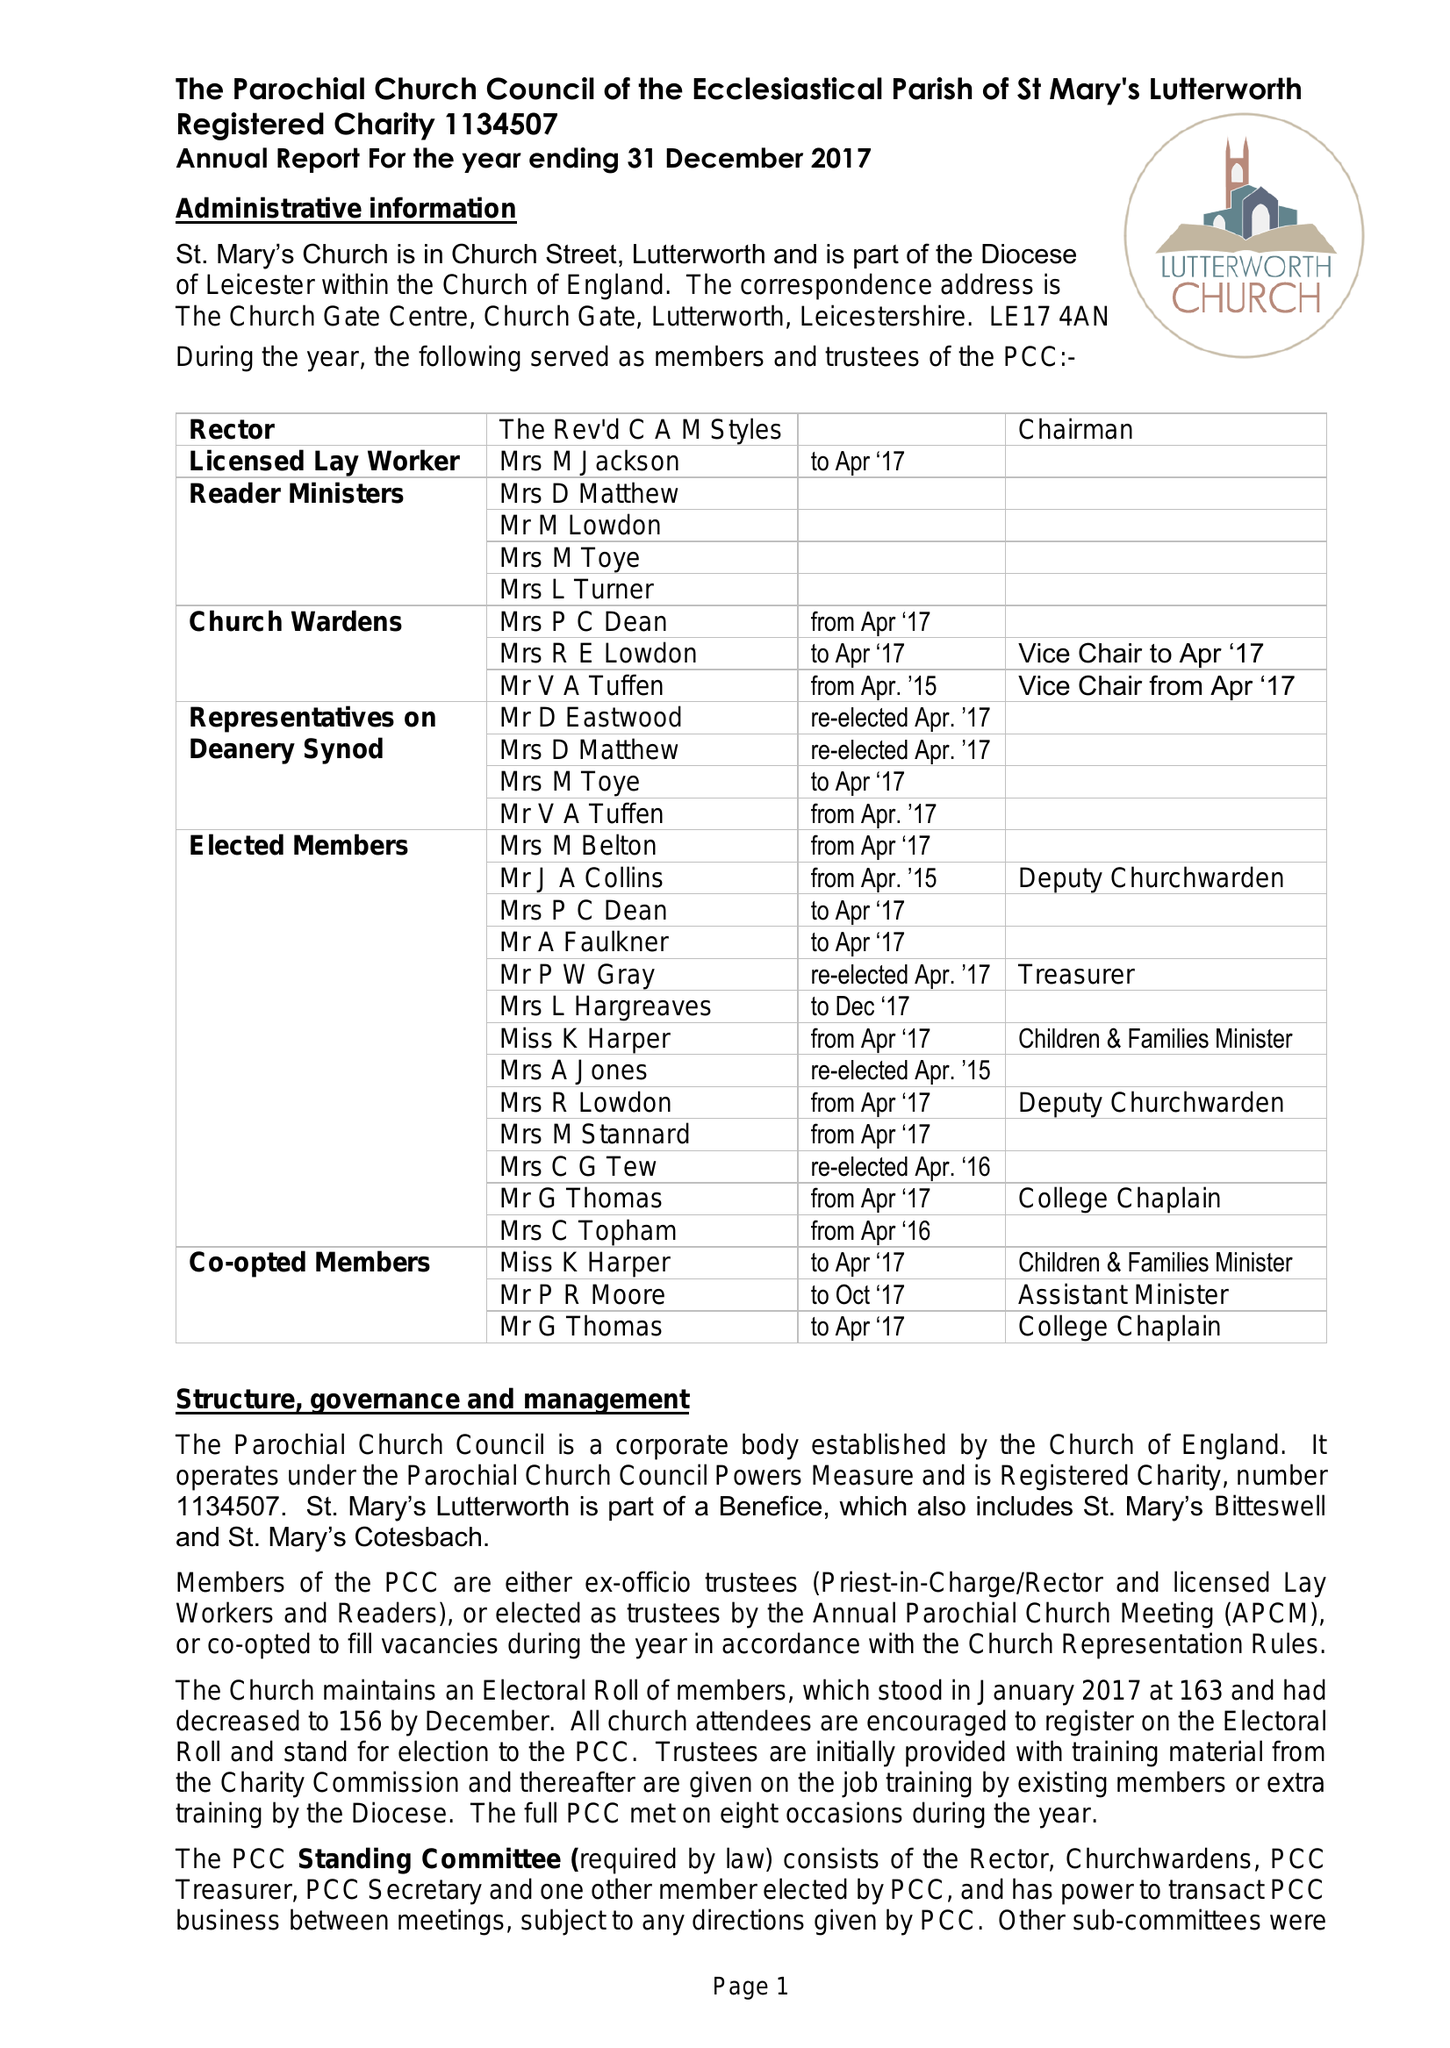What is the value for the address__street_line?
Answer the question using a single word or phrase. CHURCH GATE 